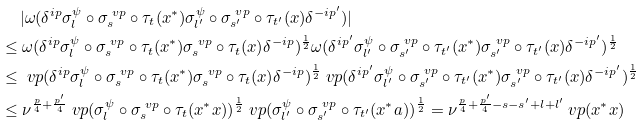Convert formula to latex. <formula><loc_0><loc_0><loc_500><loc_500>& \quad \, | \omega ( \delta ^ { i p } \sigma ^ { \psi } _ { l } \circ \sigma ^ { \ v p } _ { s } \circ \tau _ { t } ( x ^ { * } ) \sigma ^ { \psi } _ { l ^ { \prime } } \circ \sigma ^ { \ v p } _ { s ^ { \prime } } \circ \tau _ { t ^ { \prime } } ( x ) \delta ^ { - i p ^ { \prime } } ) | \\ & \leq \omega ( \delta ^ { i p } \sigma ^ { \psi } _ { l } \circ \sigma ^ { \ v p } _ { s } \circ \tau _ { t } ( x ^ { * } ) \sigma ^ { \ v p } _ { s } \circ \tau _ { t } ( x ) \delta ^ { - i p } ) ^ { \frac { 1 } { 2 } } \omega ( \delta ^ { i p ^ { \prime } } \sigma ^ { \psi } _ { l ^ { \prime } } \circ \sigma ^ { \ v p } _ { s ^ { \prime } } \circ \tau _ { t ^ { \prime } } ( x ^ { * } ) \sigma ^ { \ v p } _ { s ^ { \prime } } \circ \tau _ { t ^ { \prime } } ( x ) \delta ^ { - i p ^ { \prime } } ) ^ { \frac { 1 } { 2 } } \\ & \leq \ v p ( \delta ^ { i p } \sigma ^ { \psi } _ { l } \circ \sigma ^ { \ v p } _ { s } \circ \tau _ { t } ( x ^ { * } ) \sigma ^ { \ v p } _ { s } \circ \tau _ { t } ( x ) \delta ^ { - i p } ) ^ { \frac { 1 } { 2 } } \ v p ( \delta ^ { i p ^ { \prime } } \sigma ^ { \psi } _ { l ^ { \prime } } \circ \sigma ^ { \ v p } _ { s ^ { \prime } } \circ \tau _ { t ^ { \prime } } ( x ^ { * } ) \sigma ^ { \ v p } _ { s ^ { \prime } } \circ \tau _ { t ^ { \prime } } ( x ) \delta ^ { - i p ^ { \prime } } ) ^ { \frac { 1 } { 2 } } \\ & \leq \nu ^ { \frac { p } { 4 } + \frac { p ^ { \prime } } { 4 } } \ v p ( \sigma ^ { \psi } _ { l } \circ \sigma ^ { \ v p } _ { s } \circ \tau _ { t } ( x ^ { * } x ) ) ^ { \frac { 1 } { 2 } } \ v p ( \sigma ^ { \psi } _ { l ^ { \prime } } \circ \sigma ^ { \ v p } _ { s ^ { \prime } } \circ \tau _ { t ^ { \prime } } ( x ^ { * } a ) ) ^ { \frac { 1 } { 2 } } = \nu ^ { \frac { p } { 4 } + \frac { p ^ { \prime } } { 4 } - s - s ^ { \prime } + l + l ^ { \prime } } \ v p ( x ^ { * } x )</formula> 